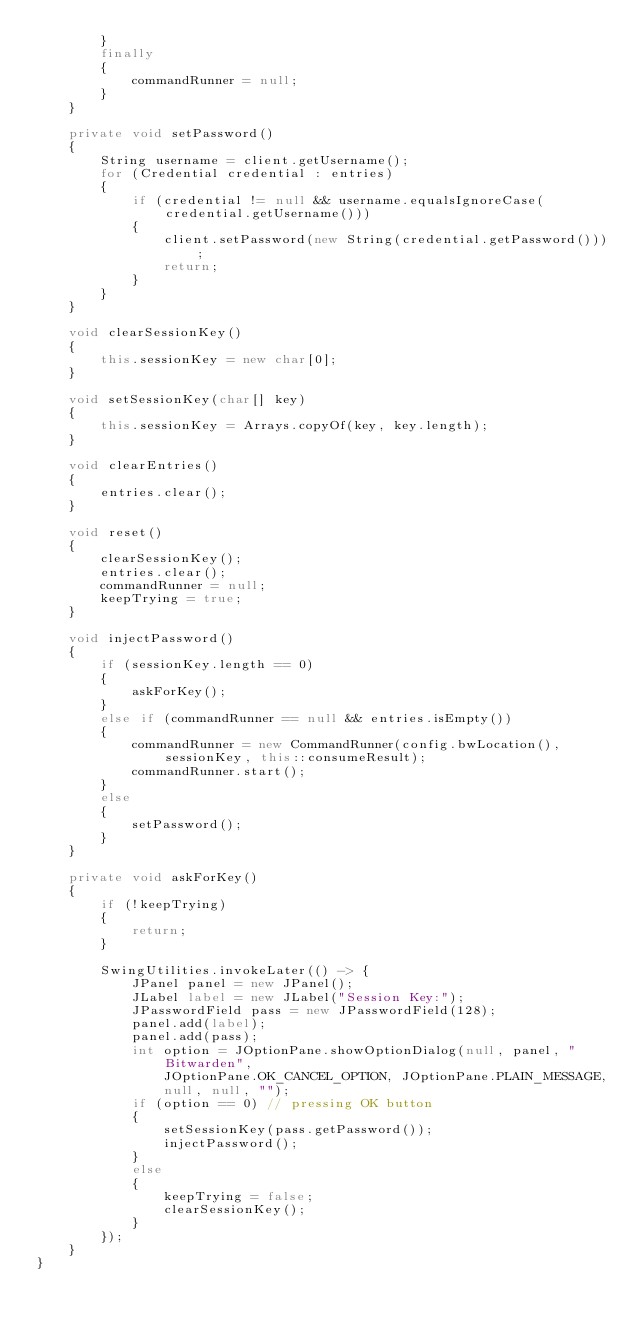<code> <loc_0><loc_0><loc_500><loc_500><_Java_>		}
		finally
		{
			commandRunner = null;
		}
	}

	private void setPassword()
	{
		String username = client.getUsername();
		for (Credential credential : entries)
		{
			if (credential != null && username.equalsIgnoreCase(credential.getUsername()))
			{
				client.setPassword(new String(credential.getPassword()));
				return;
			}
		}
	}

	void clearSessionKey()
	{
		this.sessionKey = new char[0];
	}

	void setSessionKey(char[] key)
	{
		this.sessionKey = Arrays.copyOf(key, key.length);
	}

	void clearEntries()
	{
		entries.clear();
	}

	void reset()
	{
		clearSessionKey();
		entries.clear();
		commandRunner = null;
		keepTrying = true;
	}

	void injectPassword()
	{
		if (sessionKey.length == 0)
		{
			askForKey();
		}
		else if (commandRunner == null && entries.isEmpty())
		{
			commandRunner = new CommandRunner(config.bwLocation(), sessionKey, this::consumeResult);
			commandRunner.start();
		}
		else
		{
			setPassword();
		}
	}

	private void askForKey()
	{
		if (!keepTrying)
		{
			return;
		}

		SwingUtilities.invokeLater(() -> {
			JPanel panel = new JPanel();
			JLabel label = new JLabel("Session Key:");
			JPasswordField pass = new JPasswordField(128);
			panel.add(label);
			panel.add(pass);
			int option = JOptionPane.showOptionDialog(null, panel, "Bitwarden",
				JOptionPane.OK_CANCEL_OPTION, JOptionPane.PLAIN_MESSAGE,
				null, null, "");
			if (option == 0) // pressing OK button
			{
				setSessionKey(pass.getPassword());
				injectPassword();
			}
			else
			{
				keepTrying = false;
				clearSessionKey();
			}
		});
	}
}
</code> 